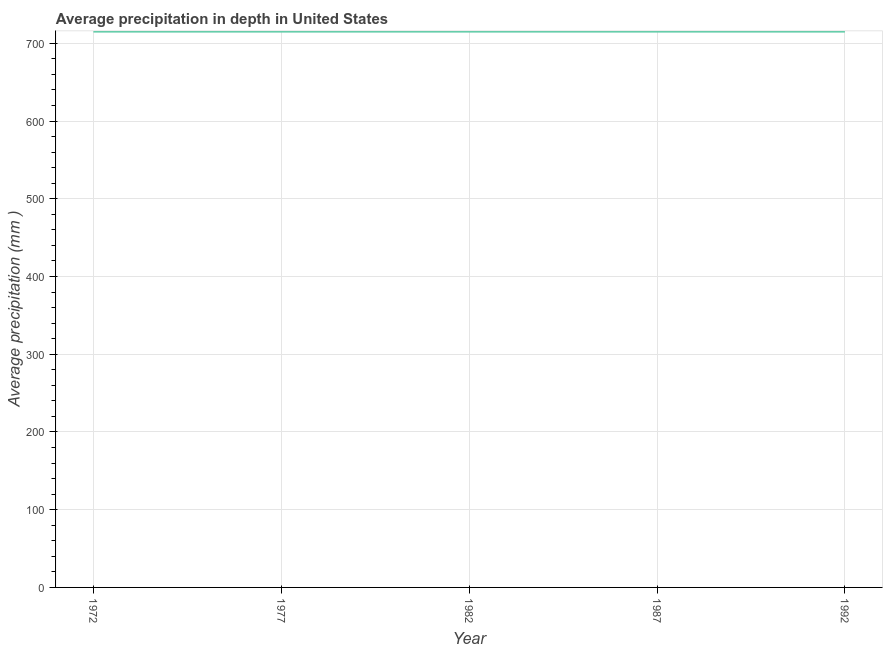What is the average precipitation in depth in 1977?
Offer a terse response. 715. Across all years, what is the maximum average precipitation in depth?
Offer a terse response. 715. Across all years, what is the minimum average precipitation in depth?
Provide a succinct answer. 715. In which year was the average precipitation in depth minimum?
Keep it short and to the point. 1972. What is the sum of the average precipitation in depth?
Provide a succinct answer. 3575. What is the average average precipitation in depth per year?
Your answer should be very brief. 715. What is the median average precipitation in depth?
Your response must be concise. 715. Do a majority of the years between 1982 and 1972 (inclusive) have average precipitation in depth greater than 80 mm?
Offer a terse response. No. Is the average precipitation in depth in 1982 less than that in 1992?
Your answer should be very brief. No. What is the difference between the highest and the second highest average precipitation in depth?
Provide a short and direct response. 0. Is the sum of the average precipitation in depth in 1972 and 1987 greater than the maximum average precipitation in depth across all years?
Offer a very short reply. Yes. What is the difference between the highest and the lowest average precipitation in depth?
Offer a very short reply. 0. Does the average precipitation in depth monotonically increase over the years?
Keep it short and to the point. No. Does the graph contain any zero values?
Offer a very short reply. No. What is the title of the graph?
Offer a very short reply. Average precipitation in depth in United States. What is the label or title of the X-axis?
Provide a short and direct response. Year. What is the label or title of the Y-axis?
Your answer should be very brief. Average precipitation (mm ). What is the Average precipitation (mm ) in 1972?
Your answer should be compact. 715. What is the Average precipitation (mm ) of 1977?
Provide a short and direct response. 715. What is the Average precipitation (mm ) in 1982?
Your answer should be very brief. 715. What is the Average precipitation (mm ) in 1987?
Provide a succinct answer. 715. What is the Average precipitation (mm ) of 1992?
Ensure brevity in your answer.  715. What is the difference between the Average precipitation (mm ) in 1972 and 1977?
Provide a short and direct response. 0. What is the difference between the Average precipitation (mm ) in 1972 and 1982?
Give a very brief answer. 0. What is the difference between the Average precipitation (mm ) in 1977 and 1982?
Your answer should be very brief. 0. What is the difference between the Average precipitation (mm ) in 1977 and 1987?
Give a very brief answer. 0. What is the difference between the Average precipitation (mm ) in 1977 and 1992?
Ensure brevity in your answer.  0. What is the difference between the Average precipitation (mm ) in 1982 and 1992?
Your response must be concise. 0. What is the ratio of the Average precipitation (mm ) in 1972 to that in 1982?
Your answer should be very brief. 1. What is the ratio of the Average precipitation (mm ) in 1972 to that in 1987?
Offer a terse response. 1. What is the ratio of the Average precipitation (mm ) in 1972 to that in 1992?
Give a very brief answer. 1. What is the ratio of the Average precipitation (mm ) in 1977 to that in 1982?
Give a very brief answer. 1. What is the ratio of the Average precipitation (mm ) in 1977 to that in 1992?
Give a very brief answer. 1. 